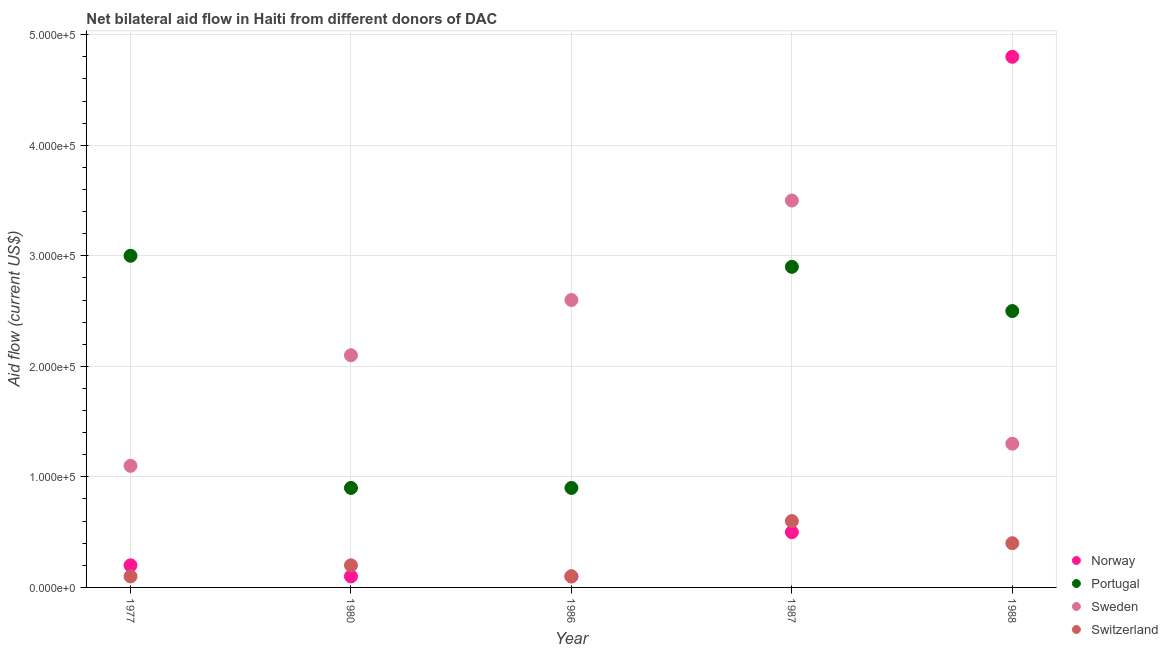How many different coloured dotlines are there?
Ensure brevity in your answer.  4. Is the number of dotlines equal to the number of legend labels?
Make the answer very short. Yes. What is the amount of aid given by norway in 1987?
Give a very brief answer. 5.00e+04. Across all years, what is the maximum amount of aid given by norway?
Make the answer very short. 4.80e+05. Across all years, what is the minimum amount of aid given by sweden?
Keep it short and to the point. 1.10e+05. In which year was the amount of aid given by switzerland maximum?
Ensure brevity in your answer.  1987. What is the total amount of aid given by norway in the graph?
Provide a short and direct response. 5.70e+05. What is the difference between the amount of aid given by sweden in 1986 and that in 1987?
Offer a very short reply. -9.00e+04. What is the difference between the amount of aid given by portugal in 1988 and the amount of aid given by sweden in 1986?
Provide a succinct answer. -10000. What is the average amount of aid given by norway per year?
Offer a very short reply. 1.14e+05. In the year 1986, what is the difference between the amount of aid given by norway and amount of aid given by sweden?
Offer a terse response. -2.50e+05. What is the ratio of the amount of aid given by switzerland in 1977 to that in 1980?
Ensure brevity in your answer.  0.5. Is the difference between the amount of aid given by portugal in 1986 and 1988 greater than the difference between the amount of aid given by sweden in 1986 and 1988?
Give a very brief answer. No. What is the difference between the highest and the second highest amount of aid given by sweden?
Your answer should be compact. 9.00e+04. What is the difference between the highest and the lowest amount of aid given by norway?
Offer a terse response. 4.70e+05. In how many years, is the amount of aid given by portugal greater than the average amount of aid given by portugal taken over all years?
Provide a succinct answer. 3. Is the sum of the amount of aid given by switzerland in 1980 and 1987 greater than the maximum amount of aid given by portugal across all years?
Make the answer very short. No. Is it the case that in every year, the sum of the amount of aid given by norway and amount of aid given by portugal is greater than the amount of aid given by sweden?
Offer a terse response. No. Is the amount of aid given by switzerland strictly greater than the amount of aid given by sweden over the years?
Give a very brief answer. No. Is the amount of aid given by norway strictly less than the amount of aid given by portugal over the years?
Your answer should be very brief. No. What is the difference between two consecutive major ticks on the Y-axis?
Give a very brief answer. 1.00e+05. Are the values on the major ticks of Y-axis written in scientific E-notation?
Make the answer very short. Yes. Does the graph contain grids?
Your answer should be compact. Yes. How many legend labels are there?
Offer a terse response. 4. How are the legend labels stacked?
Give a very brief answer. Vertical. What is the title of the graph?
Provide a succinct answer. Net bilateral aid flow in Haiti from different donors of DAC. What is the label or title of the Y-axis?
Your answer should be compact. Aid flow (current US$). What is the Aid flow (current US$) of Norway in 1977?
Provide a succinct answer. 2.00e+04. What is the Aid flow (current US$) of Portugal in 1977?
Give a very brief answer. 3.00e+05. What is the Aid flow (current US$) in Sweden in 1977?
Your answer should be compact. 1.10e+05. What is the Aid flow (current US$) in Switzerland in 1977?
Ensure brevity in your answer.  10000. What is the Aid flow (current US$) in Norway in 1980?
Ensure brevity in your answer.  10000. What is the Aid flow (current US$) of Norway in 1986?
Provide a short and direct response. 10000. What is the Aid flow (current US$) in Portugal in 1986?
Provide a short and direct response. 9.00e+04. What is the Aid flow (current US$) in Sweden in 1986?
Your response must be concise. 2.60e+05. What is the Aid flow (current US$) of Portugal in 1987?
Give a very brief answer. 2.90e+05. What is the Aid flow (current US$) of Sweden in 1987?
Your answer should be very brief. 3.50e+05. What is the Aid flow (current US$) in Norway in 1988?
Offer a very short reply. 4.80e+05. What is the Aid flow (current US$) of Portugal in 1988?
Your answer should be compact. 2.50e+05. Across all years, what is the maximum Aid flow (current US$) of Norway?
Give a very brief answer. 4.80e+05. Across all years, what is the maximum Aid flow (current US$) of Portugal?
Provide a short and direct response. 3.00e+05. Across all years, what is the maximum Aid flow (current US$) in Sweden?
Make the answer very short. 3.50e+05. Across all years, what is the minimum Aid flow (current US$) in Sweden?
Provide a short and direct response. 1.10e+05. What is the total Aid flow (current US$) in Norway in the graph?
Ensure brevity in your answer.  5.70e+05. What is the total Aid flow (current US$) of Portugal in the graph?
Your response must be concise. 1.02e+06. What is the total Aid flow (current US$) in Sweden in the graph?
Provide a succinct answer. 1.06e+06. What is the total Aid flow (current US$) in Switzerland in the graph?
Your answer should be very brief. 1.40e+05. What is the difference between the Aid flow (current US$) of Norway in 1977 and that in 1980?
Your answer should be very brief. 10000. What is the difference between the Aid flow (current US$) in Norway in 1977 and that in 1986?
Provide a succinct answer. 10000. What is the difference between the Aid flow (current US$) of Portugal in 1977 and that in 1986?
Offer a very short reply. 2.10e+05. What is the difference between the Aid flow (current US$) of Switzerland in 1977 and that in 1986?
Your answer should be very brief. 0. What is the difference between the Aid flow (current US$) in Sweden in 1977 and that in 1987?
Make the answer very short. -2.40e+05. What is the difference between the Aid flow (current US$) of Switzerland in 1977 and that in 1987?
Make the answer very short. -5.00e+04. What is the difference between the Aid flow (current US$) in Norway in 1977 and that in 1988?
Keep it short and to the point. -4.60e+05. What is the difference between the Aid flow (current US$) of Norway in 1980 and that in 1986?
Make the answer very short. 0. What is the difference between the Aid flow (current US$) in Portugal in 1980 and that in 1986?
Your answer should be compact. 0. What is the difference between the Aid flow (current US$) of Sweden in 1980 and that in 1986?
Give a very brief answer. -5.00e+04. What is the difference between the Aid flow (current US$) in Norway in 1980 and that in 1988?
Make the answer very short. -4.70e+05. What is the difference between the Aid flow (current US$) of Portugal in 1980 and that in 1988?
Your response must be concise. -1.60e+05. What is the difference between the Aid flow (current US$) of Sweden in 1980 and that in 1988?
Your answer should be compact. 8.00e+04. What is the difference between the Aid flow (current US$) in Norway in 1986 and that in 1987?
Give a very brief answer. -4.00e+04. What is the difference between the Aid flow (current US$) of Portugal in 1986 and that in 1987?
Offer a very short reply. -2.00e+05. What is the difference between the Aid flow (current US$) of Switzerland in 1986 and that in 1987?
Your response must be concise. -5.00e+04. What is the difference between the Aid flow (current US$) of Norway in 1986 and that in 1988?
Give a very brief answer. -4.70e+05. What is the difference between the Aid flow (current US$) in Norway in 1987 and that in 1988?
Your response must be concise. -4.30e+05. What is the difference between the Aid flow (current US$) of Portugal in 1987 and that in 1988?
Provide a succinct answer. 4.00e+04. What is the difference between the Aid flow (current US$) of Sweden in 1987 and that in 1988?
Your response must be concise. 2.20e+05. What is the difference between the Aid flow (current US$) in Norway in 1977 and the Aid flow (current US$) in Sweden in 1980?
Give a very brief answer. -1.90e+05. What is the difference between the Aid flow (current US$) of Portugal in 1977 and the Aid flow (current US$) of Switzerland in 1980?
Provide a short and direct response. 2.80e+05. What is the difference between the Aid flow (current US$) of Norway in 1977 and the Aid flow (current US$) of Portugal in 1986?
Your response must be concise. -7.00e+04. What is the difference between the Aid flow (current US$) in Norway in 1977 and the Aid flow (current US$) in Sweden in 1986?
Your response must be concise. -2.40e+05. What is the difference between the Aid flow (current US$) in Sweden in 1977 and the Aid flow (current US$) in Switzerland in 1986?
Your answer should be compact. 1.00e+05. What is the difference between the Aid flow (current US$) of Norway in 1977 and the Aid flow (current US$) of Sweden in 1987?
Give a very brief answer. -3.30e+05. What is the difference between the Aid flow (current US$) in Norway in 1977 and the Aid flow (current US$) in Switzerland in 1987?
Offer a terse response. -4.00e+04. What is the difference between the Aid flow (current US$) in Portugal in 1977 and the Aid flow (current US$) in Sweden in 1987?
Provide a succinct answer. -5.00e+04. What is the difference between the Aid flow (current US$) of Norway in 1977 and the Aid flow (current US$) of Portugal in 1988?
Keep it short and to the point. -2.30e+05. What is the difference between the Aid flow (current US$) in Norway in 1977 and the Aid flow (current US$) in Sweden in 1988?
Provide a short and direct response. -1.10e+05. What is the difference between the Aid flow (current US$) of Portugal in 1977 and the Aid flow (current US$) of Sweden in 1988?
Provide a succinct answer. 1.70e+05. What is the difference between the Aid flow (current US$) of Portugal in 1977 and the Aid flow (current US$) of Switzerland in 1988?
Keep it short and to the point. 2.60e+05. What is the difference between the Aid flow (current US$) in Norway in 1980 and the Aid flow (current US$) in Portugal in 1986?
Your answer should be compact. -8.00e+04. What is the difference between the Aid flow (current US$) of Sweden in 1980 and the Aid flow (current US$) of Switzerland in 1986?
Ensure brevity in your answer.  2.00e+05. What is the difference between the Aid flow (current US$) of Norway in 1980 and the Aid flow (current US$) of Portugal in 1987?
Ensure brevity in your answer.  -2.80e+05. What is the difference between the Aid flow (current US$) in Portugal in 1980 and the Aid flow (current US$) in Switzerland in 1987?
Your response must be concise. 3.00e+04. What is the difference between the Aid flow (current US$) of Sweden in 1980 and the Aid flow (current US$) of Switzerland in 1987?
Your response must be concise. 1.50e+05. What is the difference between the Aid flow (current US$) in Norway in 1980 and the Aid flow (current US$) in Portugal in 1988?
Ensure brevity in your answer.  -2.40e+05. What is the difference between the Aid flow (current US$) in Norway in 1980 and the Aid flow (current US$) in Sweden in 1988?
Your response must be concise. -1.20e+05. What is the difference between the Aid flow (current US$) in Norway in 1980 and the Aid flow (current US$) in Switzerland in 1988?
Provide a short and direct response. -3.00e+04. What is the difference between the Aid flow (current US$) in Portugal in 1980 and the Aid flow (current US$) in Sweden in 1988?
Offer a terse response. -4.00e+04. What is the difference between the Aid flow (current US$) of Norway in 1986 and the Aid flow (current US$) of Portugal in 1987?
Your answer should be compact. -2.80e+05. What is the difference between the Aid flow (current US$) of Norway in 1986 and the Aid flow (current US$) of Switzerland in 1987?
Provide a short and direct response. -5.00e+04. What is the difference between the Aid flow (current US$) of Portugal in 1986 and the Aid flow (current US$) of Sweden in 1987?
Ensure brevity in your answer.  -2.60e+05. What is the difference between the Aid flow (current US$) in Norway in 1986 and the Aid flow (current US$) in Portugal in 1988?
Ensure brevity in your answer.  -2.40e+05. What is the difference between the Aid flow (current US$) of Sweden in 1986 and the Aid flow (current US$) of Switzerland in 1988?
Your answer should be very brief. 2.20e+05. What is the difference between the Aid flow (current US$) of Norway in 1987 and the Aid flow (current US$) of Sweden in 1988?
Provide a short and direct response. -8.00e+04. What is the difference between the Aid flow (current US$) in Norway in 1987 and the Aid flow (current US$) in Switzerland in 1988?
Keep it short and to the point. 10000. What is the difference between the Aid flow (current US$) of Portugal in 1987 and the Aid flow (current US$) of Sweden in 1988?
Make the answer very short. 1.60e+05. What is the average Aid flow (current US$) of Norway per year?
Provide a succinct answer. 1.14e+05. What is the average Aid flow (current US$) of Portugal per year?
Make the answer very short. 2.04e+05. What is the average Aid flow (current US$) of Sweden per year?
Your answer should be very brief. 2.12e+05. What is the average Aid flow (current US$) of Switzerland per year?
Keep it short and to the point. 2.80e+04. In the year 1977, what is the difference between the Aid flow (current US$) in Norway and Aid flow (current US$) in Portugal?
Ensure brevity in your answer.  -2.80e+05. In the year 1977, what is the difference between the Aid flow (current US$) in Norway and Aid flow (current US$) in Sweden?
Provide a succinct answer. -9.00e+04. In the year 1977, what is the difference between the Aid flow (current US$) in Portugal and Aid flow (current US$) in Switzerland?
Provide a short and direct response. 2.90e+05. In the year 1980, what is the difference between the Aid flow (current US$) in Norway and Aid flow (current US$) in Portugal?
Make the answer very short. -8.00e+04. In the year 1980, what is the difference between the Aid flow (current US$) in Norway and Aid flow (current US$) in Sweden?
Your response must be concise. -2.00e+05. In the year 1980, what is the difference between the Aid flow (current US$) of Norway and Aid flow (current US$) of Switzerland?
Provide a succinct answer. -10000. In the year 1980, what is the difference between the Aid flow (current US$) of Portugal and Aid flow (current US$) of Sweden?
Offer a very short reply. -1.20e+05. In the year 1980, what is the difference between the Aid flow (current US$) of Portugal and Aid flow (current US$) of Switzerland?
Offer a very short reply. 7.00e+04. In the year 1986, what is the difference between the Aid flow (current US$) in Norway and Aid flow (current US$) in Portugal?
Offer a terse response. -8.00e+04. In the year 1986, what is the difference between the Aid flow (current US$) of Portugal and Aid flow (current US$) of Sweden?
Your response must be concise. -1.70e+05. In the year 1987, what is the difference between the Aid flow (current US$) of Norway and Aid flow (current US$) of Portugal?
Your answer should be very brief. -2.40e+05. In the year 1987, what is the difference between the Aid flow (current US$) of Norway and Aid flow (current US$) of Switzerland?
Ensure brevity in your answer.  -10000. In the year 1987, what is the difference between the Aid flow (current US$) in Portugal and Aid flow (current US$) in Sweden?
Offer a very short reply. -6.00e+04. In the year 1987, what is the difference between the Aid flow (current US$) of Portugal and Aid flow (current US$) of Switzerland?
Give a very brief answer. 2.30e+05. In the year 1987, what is the difference between the Aid flow (current US$) in Sweden and Aid flow (current US$) in Switzerland?
Ensure brevity in your answer.  2.90e+05. In the year 1988, what is the difference between the Aid flow (current US$) of Portugal and Aid flow (current US$) of Sweden?
Give a very brief answer. 1.20e+05. In the year 1988, what is the difference between the Aid flow (current US$) in Sweden and Aid flow (current US$) in Switzerland?
Keep it short and to the point. 9.00e+04. What is the ratio of the Aid flow (current US$) of Portugal in 1977 to that in 1980?
Give a very brief answer. 3.33. What is the ratio of the Aid flow (current US$) of Sweden in 1977 to that in 1980?
Provide a succinct answer. 0.52. What is the ratio of the Aid flow (current US$) in Sweden in 1977 to that in 1986?
Your answer should be very brief. 0.42. What is the ratio of the Aid flow (current US$) of Norway in 1977 to that in 1987?
Offer a terse response. 0.4. What is the ratio of the Aid flow (current US$) of Portugal in 1977 to that in 1987?
Provide a short and direct response. 1.03. What is the ratio of the Aid flow (current US$) of Sweden in 1977 to that in 1987?
Provide a short and direct response. 0.31. What is the ratio of the Aid flow (current US$) of Switzerland in 1977 to that in 1987?
Offer a terse response. 0.17. What is the ratio of the Aid flow (current US$) of Norway in 1977 to that in 1988?
Offer a very short reply. 0.04. What is the ratio of the Aid flow (current US$) in Portugal in 1977 to that in 1988?
Ensure brevity in your answer.  1.2. What is the ratio of the Aid flow (current US$) of Sweden in 1977 to that in 1988?
Offer a very short reply. 0.85. What is the ratio of the Aid flow (current US$) of Switzerland in 1977 to that in 1988?
Provide a succinct answer. 0.25. What is the ratio of the Aid flow (current US$) of Portugal in 1980 to that in 1986?
Give a very brief answer. 1. What is the ratio of the Aid flow (current US$) in Sweden in 1980 to that in 1986?
Your response must be concise. 0.81. What is the ratio of the Aid flow (current US$) of Portugal in 1980 to that in 1987?
Ensure brevity in your answer.  0.31. What is the ratio of the Aid flow (current US$) in Switzerland in 1980 to that in 1987?
Offer a very short reply. 0.33. What is the ratio of the Aid flow (current US$) in Norway in 1980 to that in 1988?
Your answer should be compact. 0.02. What is the ratio of the Aid flow (current US$) of Portugal in 1980 to that in 1988?
Keep it short and to the point. 0.36. What is the ratio of the Aid flow (current US$) of Sweden in 1980 to that in 1988?
Provide a succinct answer. 1.62. What is the ratio of the Aid flow (current US$) in Switzerland in 1980 to that in 1988?
Give a very brief answer. 0.5. What is the ratio of the Aid flow (current US$) of Norway in 1986 to that in 1987?
Offer a very short reply. 0.2. What is the ratio of the Aid flow (current US$) in Portugal in 1986 to that in 1987?
Keep it short and to the point. 0.31. What is the ratio of the Aid flow (current US$) in Sweden in 1986 to that in 1987?
Your response must be concise. 0.74. What is the ratio of the Aid flow (current US$) in Norway in 1986 to that in 1988?
Provide a short and direct response. 0.02. What is the ratio of the Aid flow (current US$) in Portugal in 1986 to that in 1988?
Give a very brief answer. 0.36. What is the ratio of the Aid flow (current US$) in Sweden in 1986 to that in 1988?
Make the answer very short. 2. What is the ratio of the Aid flow (current US$) of Norway in 1987 to that in 1988?
Make the answer very short. 0.1. What is the ratio of the Aid flow (current US$) in Portugal in 1987 to that in 1988?
Your response must be concise. 1.16. What is the ratio of the Aid flow (current US$) of Sweden in 1987 to that in 1988?
Keep it short and to the point. 2.69. What is the ratio of the Aid flow (current US$) of Switzerland in 1987 to that in 1988?
Provide a short and direct response. 1.5. What is the difference between the highest and the second highest Aid flow (current US$) of Sweden?
Provide a succinct answer. 9.00e+04. What is the difference between the highest and the second highest Aid flow (current US$) in Switzerland?
Give a very brief answer. 2.00e+04. What is the difference between the highest and the lowest Aid flow (current US$) in Portugal?
Your answer should be compact. 2.10e+05. What is the difference between the highest and the lowest Aid flow (current US$) in Sweden?
Your response must be concise. 2.40e+05. What is the difference between the highest and the lowest Aid flow (current US$) in Switzerland?
Offer a very short reply. 5.00e+04. 